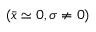<formula> <loc_0><loc_0><loc_500><loc_500>( \bar { x } \simeq 0 , \sigma \neq 0 )</formula> 